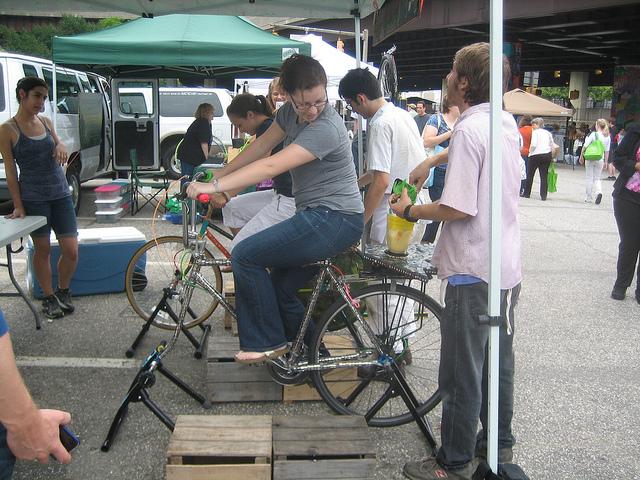Where is the cooler?
Give a very brief answer. Cooler is under tent. How many tires does the bike in the forefront have?
Quick response, please. 1. Are they parking the cycle?
Keep it brief. No. 